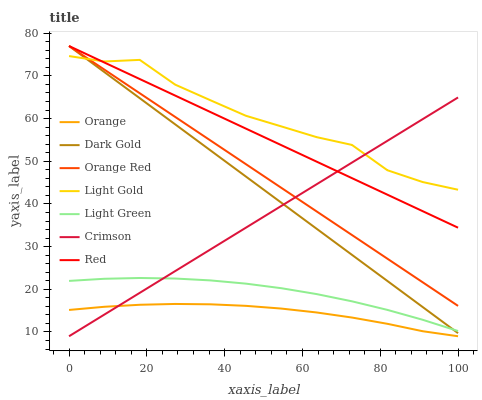Does Crimson have the minimum area under the curve?
Answer yes or no. No. Does Crimson have the maximum area under the curve?
Answer yes or no. No. Is Crimson the smoothest?
Answer yes or no. No. Is Crimson the roughest?
Answer yes or no. No. Does Light Green have the lowest value?
Answer yes or no. No. Does Crimson have the highest value?
Answer yes or no. No. Is Light Green less than Orange Red?
Answer yes or no. Yes. Is Orange Red greater than Light Green?
Answer yes or no. Yes. Does Light Green intersect Orange Red?
Answer yes or no. No. 